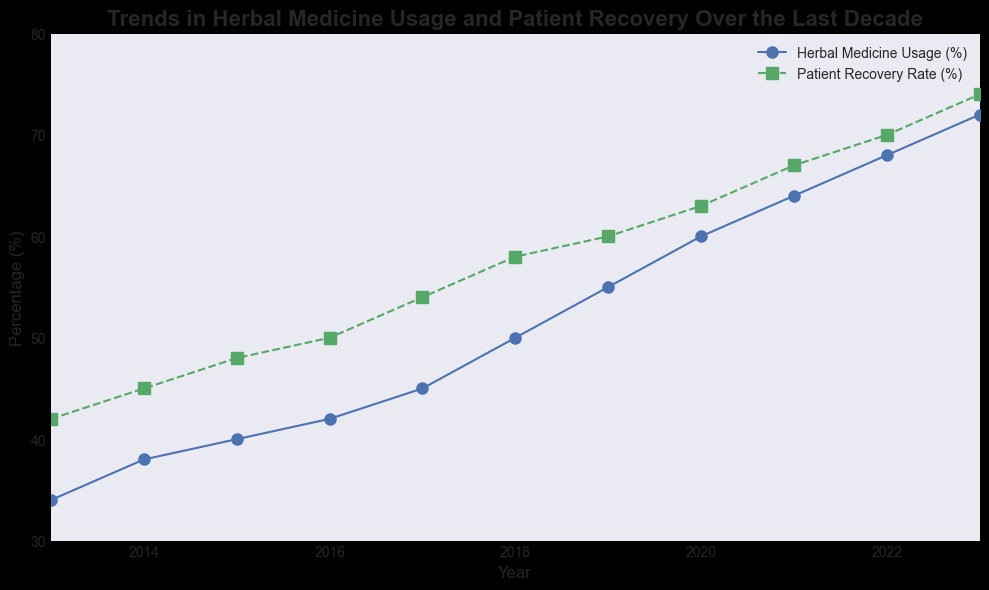What is the total increase in herbal medicine usage from 2013 to 2023? To find the total increase, subtract the herbal medicine usage in 2013 from that in 2023. The herbal medicine usage in 2013 was 34%, and in 2023 it is 72%. So, the increase is 72% - 34%.
Answer: 38% Between which years did the patient recovery rate grow the most? To identify this, observe the year-to-year differences in the patient recovery rate. The largest increase is between 2017 to 2018, where it grew from 54% to 58%, a difference of 4%.
Answer: 2017 to 2018 Which year had an equal increase in both herbal medicine usage and patient recovery rate compared to the previous year? Look at each year's increase for both metrics. Only in 2021, both the herbal medicine usage (from 60% to 64%) and the patient recovery rate (from 63% to 67%) had identical increases of 4%.
Answer: 2021 How did the patient recovery rate change from 2013 to 2019? To determine the change, subtract the 2013 recovery rate from the 2019 recovery rate. The recovery rate in 2013 was 42%, and in 2019 it was 60%. So, the change is 60% - 42%.
Answer: 18% In what year did the patient recovery rate first exceed 60%? Observation of the plotted line for patient recovery rates shows that the rate first exceeds 60% in the year 2020.
Answer: 2020 Is the herbal medicine usage rate always increasing? By observing the continuous upward trend of the herbal medicine usage line, it is clear the rate increases steadily from 2013 to 2023.
Answer: Yes Which year showed the highest patient recovery rate? The highest point on the patient recovery rate line occurs in 2023, with a rate of 74%.
Answer: 2023 Compare the increase in patient recovery rate between 2021 and 2022 with that between 2022 and 2023. Which was greater? The increase from 2021 to 2022 is 67% - 70% = 3%, and from 2022 to 2023 it is 70% - 74% = 4%. The increase from 2022 to 2023 is greater by 1%.
Answer: 2022 to 2023 